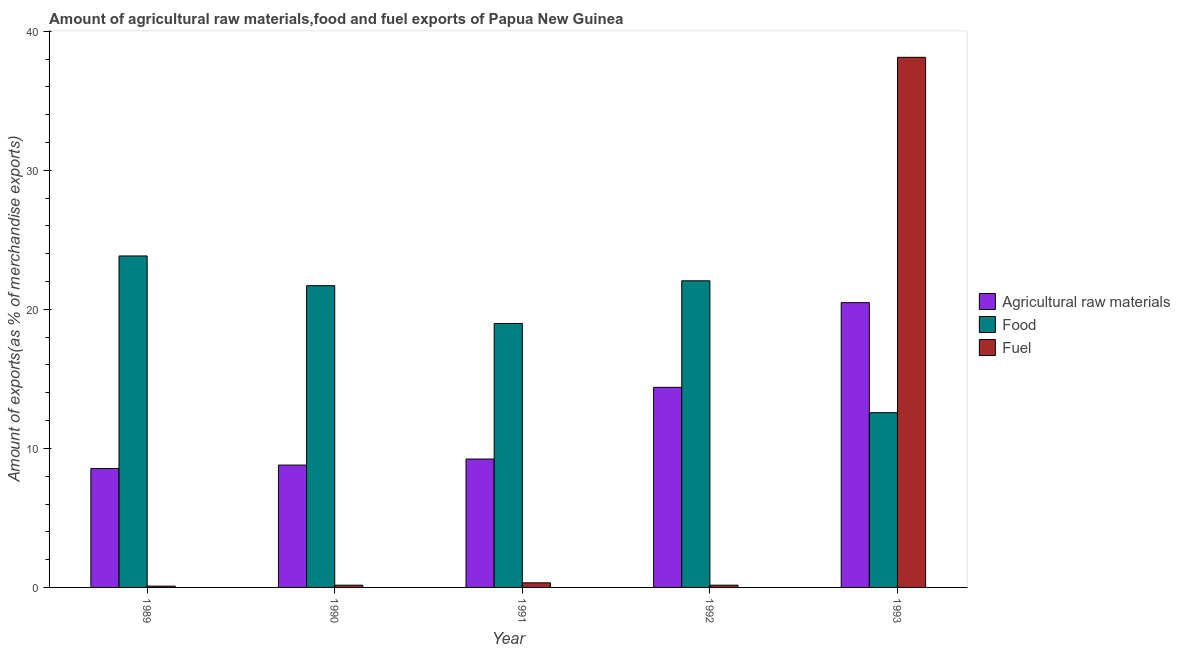How many bars are there on the 5th tick from the left?
Offer a very short reply. 3. What is the label of the 2nd group of bars from the left?
Offer a very short reply. 1990. What is the percentage of food exports in 1990?
Your answer should be compact. 21.71. Across all years, what is the maximum percentage of food exports?
Offer a terse response. 23.84. Across all years, what is the minimum percentage of fuel exports?
Give a very brief answer. 0.09. In which year was the percentage of fuel exports maximum?
Ensure brevity in your answer.  1993. In which year was the percentage of fuel exports minimum?
Your answer should be very brief. 1989. What is the total percentage of food exports in the graph?
Your answer should be very brief. 99.16. What is the difference between the percentage of fuel exports in 1991 and that in 1993?
Provide a succinct answer. -37.8. What is the difference between the percentage of fuel exports in 1989 and the percentage of raw materials exports in 1990?
Provide a short and direct response. -0.07. What is the average percentage of fuel exports per year?
Your answer should be very brief. 7.78. In the year 1991, what is the difference between the percentage of fuel exports and percentage of food exports?
Provide a short and direct response. 0. What is the ratio of the percentage of food exports in 1992 to that in 1993?
Offer a very short reply. 1.75. Is the percentage of fuel exports in 1990 less than that in 1993?
Keep it short and to the point. Yes. Is the difference between the percentage of fuel exports in 1991 and 1992 greater than the difference between the percentage of raw materials exports in 1991 and 1992?
Provide a short and direct response. No. What is the difference between the highest and the second highest percentage of fuel exports?
Offer a very short reply. 37.8. What is the difference between the highest and the lowest percentage of food exports?
Provide a succinct answer. 11.28. Is the sum of the percentage of food exports in 1992 and 1993 greater than the maximum percentage of raw materials exports across all years?
Provide a short and direct response. Yes. What does the 3rd bar from the left in 1991 represents?
Ensure brevity in your answer.  Fuel. What does the 2nd bar from the right in 1989 represents?
Offer a very short reply. Food. What is the difference between two consecutive major ticks on the Y-axis?
Offer a terse response. 10. Does the graph contain any zero values?
Ensure brevity in your answer.  No. Does the graph contain grids?
Offer a very short reply. No. How many legend labels are there?
Keep it short and to the point. 3. What is the title of the graph?
Offer a very short reply. Amount of agricultural raw materials,food and fuel exports of Papua New Guinea. Does "Resident buildings and public services" appear as one of the legend labels in the graph?
Your answer should be very brief. No. What is the label or title of the Y-axis?
Provide a short and direct response. Amount of exports(as % of merchandise exports). What is the Amount of exports(as % of merchandise exports) in Agricultural raw materials in 1989?
Keep it short and to the point. 8.56. What is the Amount of exports(as % of merchandise exports) in Food in 1989?
Your answer should be compact. 23.84. What is the Amount of exports(as % of merchandise exports) of Fuel in 1989?
Provide a succinct answer. 0.09. What is the Amount of exports(as % of merchandise exports) of Agricultural raw materials in 1990?
Give a very brief answer. 8.8. What is the Amount of exports(as % of merchandise exports) in Food in 1990?
Keep it short and to the point. 21.71. What is the Amount of exports(as % of merchandise exports) of Fuel in 1990?
Your response must be concise. 0.16. What is the Amount of exports(as % of merchandise exports) of Agricultural raw materials in 1991?
Keep it short and to the point. 9.24. What is the Amount of exports(as % of merchandise exports) in Food in 1991?
Your answer should be compact. 18.99. What is the Amount of exports(as % of merchandise exports) of Fuel in 1991?
Offer a terse response. 0.33. What is the Amount of exports(as % of merchandise exports) in Agricultural raw materials in 1992?
Provide a succinct answer. 14.39. What is the Amount of exports(as % of merchandise exports) in Food in 1992?
Give a very brief answer. 22.06. What is the Amount of exports(as % of merchandise exports) of Fuel in 1992?
Offer a terse response. 0.16. What is the Amount of exports(as % of merchandise exports) of Agricultural raw materials in 1993?
Make the answer very short. 20.49. What is the Amount of exports(as % of merchandise exports) of Food in 1993?
Keep it short and to the point. 12.57. What is the Amount of exports(as % of merchandise exports) in Fuel in 1993?
Give a very brief answer. 38.13. Across all years, what is the maximum Amount of exports(as % of merchandise exports) in Agricultural raw materials?
Offer a terse response. 20.49. Across all years, what is the maximum Amount of exports(as % of merchandise exports) in Food?
Offer a very short reply. 23.84. Across all years, what is the maximum Amount of exports(as % of merchandise exports) in Fuel?
Offer a terse response. 38.13. Across all years, what is the minimum Amount of exports(as % of merchandise exports) in Agricultural raw materials?
Provide a succinct answer. 8.56. Across all years, what is the minimum Amount of exports(as % of merchandise exports) of Food?
Provide a short and direct response. 12.57. Across all years, what is the minimum Amount of exports(as % of merchandise exports) of Fuel?
Give a very brief answer. 0.09. What is the total Amount of exports(as % of merchandise exports) of Agricultural raw materials in the graph?
Offer a terse response. 61.47. What is the total Amount of exports(as % of merchandise exports) of Food in the graph?
Your answer should be compact. 99.16. What is the total Amount of exports(as % of merchandise exports) of Fuel in the graph?
Your answer should be very brief. 38.88. What is the difference between the Amount of exports(as % of merchandise exports) of Agricultural raw materials in 1989 and that in 1990?
Offer a very short reply. -0.24. What is the difference between the Amount of exports(as % of merchandise exports) of Food in 1989 and that in 1990?
Give a very brief answer. 2.14. What is the difference between the Amount of exports(as % of merchandise exports) of Fuel in 1989 and that in 1990?
Make the answer very short. -0.07. What is the difference between the Amount of exports(as % of merchandise exports) in Agricultural raw materials in 1989 and that in 1991?
Your answer should be compact. -0.68. What is the difference between the Amount of exports(as % of merchandise exports) in Food in 1989 and that in 1991?
Provide a short and direct response. 4.86. What is the difference between the Amount of exports(as % of merchandise exports) of Fuel in 1989 and that in 1991?
Your answer should be compact. -0.24. What is the difference between the Amount of exports(as % of merchandise exports) in Agricultural raw materials in 1989 and that in 1992?
Your response must be concise. -5.84. What is the difference between the Amount of exports(as % of merchandise exports) in Food in 1989 and that in 1992?
Make the answer very short. 1.79. What is the difference between the Amount of exports(as % of merchandise exports) in Fuel in 1989 and that in 1992?
Provide a succinct answer. -0.07. What is the difference between the Amount of exports(as % of merchandise exports) in Agricultural raw materials in 1989 and that in 1993?
Ensure brevity in your answer.  -11.93. What is the difference between the Amount of exports(as % of merchandise exports) of Food in 1989 and that in 1993?
Provide a short and direct response. 11.28. What is the difference between the Amount of exports(as % of merchandise exports) in Fuel in 1989 and that in 1993?
Offer a terse response. -38.04. What is the difference between the Amount of exports(as % of merchandise exports) in Agricultural raw materials in 1990 and that in 1991?
Provide a short and direct response. -0.43. What is the difference between the Amount of exports(as % of merchandise exports) in Food in 1990 and that in 1991?
Your response must be concise. 2.72. What is the difference between the Amount of exports(as % of merchandise exports) of Fuel in 1990 and that in 1991?
Provide a succinct answer. -0.17. What is the difference between the Amount of exports(as % of merchandise exports) of Agricultural raw materials in 1990 and that in 1992?
Your answer should be compact. -5.59. What is the difference between the Amount of exports(as % of merchandise exports) of Food in 1990 and that in 1992?
Provide a succinct answer. -0.35. What is the difference between the Amount of exports(as % of merchandise exports) in Fuel in 1990 and that in 1992?
Provide a succinct answer. -0. What is the difference between the Amount of exports(as % of merchandise exports) in Agricultural raw materials in 1990 and that in 1993?
Your answer should be compact. -11.68. What is the difference between the Amount of exports(as % of merchandise exports) of Food in 1990 and that in 1993?
Your response must be concise. 9.14. What is the difference between the Amount of exports(as % of merchandise exports) of Fuel in 1990 and that in 1993?
Ensure brevity in your answer.  -37.97. What is the difference between the Amount of exports(as % of merchandise exports) in Agricultural raw materials in 1991 and that in 1992?
Offer a terse response. -5.16. What is the difference between the Amount of exports(as % of merchandise exports) of Food in 1991 and that in 1992?
Offer a very short reply. -3.07. What is the difference between the Amount of exports(as % of merchandise exports) of Fuel in 1991 and that in 1992?
Your answer should be very brief. 0.17. What is the difference between the Amount of exports(as % of merchandise exports) in Agricultural raw materials in 1991 and that in 1993?
Your response must be concise. -11.25. What is the difference between the Amount of exports(as % of merchandise exports) in Food in 1991 and that in 1993?
Your answer should be compact. 6.42. What is the difference between the Amount of exports(as % of merchandise exports) in Fuel in 1991 and that in 1993?
Provide a short and direct response. -37.8. What is the difference between the Amount of exports(as % of merchandise exports) of Agricultural raw materials in 1992 and that in 1993?
Provide a short and direct response. -6.09. What is the difference between the Amount of exports(as % of merchandise exports) in Food in 1992 and that in 1993?
Keep it short and to the point. 9.49. What is the difference between the Amount of exports(as % of merchandise exports) of Fuel in 1992 and that in 1993?
Your answer should be compact. -37.97. What is the difference between the Amount of exports(as % of merchandise exports) in Agricultural raw materials in 1989 and the Amount of exports(as % of merchandise exports) in Food in 1990?
Provide a succinct answer. -13.15. What is the difference between the Amount of exports(as % of merchandise exports) of Agricultural raw materials in 1989 and the Amount of exports(as % of merchandise exports) of Fuel in 1990?
Ensure brevity in your answer.  8.4. What is the difference between the Amount of exports(as % of merchandise exports) in Food in 1989 and the Amount of exports(as % of merchandise exports) in Fuel in 1990?
Provide a short and direct response. 23.68. What is the difference between the Amount of exports(as % of merchandise exports) in Agricultural raw materials in 1989 and the Amount of exports(as % of merchandise exports) in Food in 1991?
Ensure brevity in your answer.  -10.43. What is the difference between the Amount of exports(as % of merchandise exports) of Agricultural raw materials in 1989 and the Amount of exports(as % of merchandise exports) of Fuel in 1991?
Your answer should be compact. 8.22. What is the difference between the Amount of exports(as % of merchandise exports) in Food in 1989 and the Amount of exports(as % of merchandise exports) in Fuel in 1991?
Offer a terse response. 23.51. What is the difference between the Amount of exports(as % of merchandise exports) of Agricultural raw materials in 1989 and the Amount of exports(as % of merchandise exports) of Food in 1992?
Offer a very short reply. -13.5. What is the difference between the Amount of exports(as % of merchandise exports) in Agricultural raw materials in 1989 and the Amount of exports(as % of merchandise exports) in Fuel in 1992?
Your answer should be very brief. 8.4. What is the difference between the Amount of exports(as % of merchandise exports) of Food in 1989 and the Amount of exports(as % of merchandise exports) of Fuel in 1992?
Your response must be concise. 23.68. What is the difference between the Amount of exports(as % of merchandise exports) of Agricultural raw materials in 1989 and the Amount of exports(as % of merchandise exports) of Food in 1993?
Your response must be concise. -4.01. What is the difference between the Amount of exports(as % of merchandise exports) of Agricultural raw materials in 1989 and the Amount of exports(as % of merchandise exports) of Fuel in 1993?
Ensure brevity in your answer.  -29.57. What is the difference between the Amount of exports(as % of merchandise exports) of Food in 1989 and the Amount of exports(as % of merchandise exports) of Fuel in 1993?
Offer a very short reply. -14.29. What is the difference between the Amount of exports(as % of merchandise exports) in Agricultural raw materials in 1990 and the Amount of exports(as % of merchandise exports) in Food in 1991?
Make the answer very short. -10.19. What is the difference between the Amount of exports(as % of merchandise exports) in Agricultural raw materials in 1990 and the Amount of exports(as % of merchandise exports) in Fuel in 1991?
Provide a succinct answer. 8.47. What is the difference between the Amount of exports(as % of merchandise exports) in Food in 1990 and the Amount of exports(as % of merchandise exports) in Fuel in 1991?
Your answer should be compact. 21.37. What is the difference between the Amount of exports(as % of merchandise exports) of Agricultural raw materials in 1990 and the Amount of exports(as % of merchandise exports) of Food in 1992?
Make the answer very short. -13.26. What is the difference between the Amount of exports(as % of merchandise exports) in Agricultural raw materials in 1990 and the Amount of exports(as % of merchandise exports) in Fuel in 1992?
Give a very brief answer. 8.64. What is the difference between the Amount of exports(as % of merchandise exports) in Food in 1990 and the Amount of exports(as % of merchandise exports) in Fuel in 1992?
Offer a terse response. 21.54. What is the difference between the Amount of exports(as % of merchandise exports) in Agricultural raw materials in 1990 and the Amount of exports(as % of merchandise exports) in Food in 1993?
Ensure brevity in your answer.  -3.77. What is the difference between the Amount of exports(as % of merchandise exports) of Agricultural raw materials in 1990 and the Amount of exports(as % of merchandise exports) of Fuel in 1993?
Offer a terse response. -29.33. What is the difference between the Amount of exports(as % of merchandise exports) of Food in 1990 and the Amount of exports(as % of merchandise exports) of Fuel in 1993?
Ensure brevity in your answer.  -16.43. What is the difference between the Amount of exports(as % of merchandise exports) of Agricultural raw materials in 1991 and the Amount of exports(as % of merchandise exports) of Food in 1992?
Ensure brevity in your answer.  -12.82. What is the difference between the Amount of exports(as % of merchandise exports) in Agricultural raw materials in 1991 and the Amount of exports(as % of merchandise exports) in Fuel in 1992?
Give a very brief answer. 9.07. What is the difference between the Amount of exports(as % of merchandise exports) in Food in 1991 and the Amount of exports(as % of merchandise exports) in Fuel in 1992?
Offer a terse response. 18.83. What is the difference between the Amount of exports(as % of merchandise exports) in Agricultural raw materials in 1991 and the Amount of exports(as % of merchandise exports) in Fuel in 1993?
Make the answer very short. -28.9. What is the difference between the Amount of exports(as % of merchandise exports) in Food in 1991 and the Amount of exports(as % of merchandise exports) in Fuel in 1993?
Keep it short and to the point. -19.15. What is the difference between the Amount of exports(as % of merchandise exports) of Agricultural raw materials in 1992 and the Amount of exports(as % of merchandise exports) of Food in 1993?
Make the answer very short. 1.82. What is the difference between the Amount of exports(as % of merchandise exports) of Agricultural raw materials in 1992 and the Amount of exports(as % of merchandise exports) of Fuel in 1993?
Offer a very short reply. -23.74. What is the difference between the Amount of exports(as % of merchandise exports) in Food in 1992 and the Amount of exports(as % of merchandise exports) in Fuel in 1993?
Keep it short and to the point. -16.08. What is the average Amount of exports(as % of merchandise exports) in Agricultural raw materials per year?
Your response must be concise. 12.29. What is the average Amount of exports(as % of merchandise exports) of Food per year?
Provide a short and direct response. 19.83. What is the average Amount of exports(as % of merchandise exports) in Fuel per year?
Make the answer very short. 7.78. In the year 1989, what is the difference between the Amount of exports(as % of merchandise exports) of Agricultural raw materials and Amount of exports(as % of merchandise exports) of Food?
Make the answer very short. -15.29. In the year 1989, what is the difference between the Amount of exports(as % of merchandise exports) in Agricultural raw materials and Amount of exports(as % of merchandise exports) in Fuel?
Your answer should be very brief. 8.46. In the year 1989, what is the difference between the Amount of exports(as % of merchandise exports) of Food and Amount of exports(as % of merchandise exports) of Fuel?
Offer a terse response. 23.75. In the year 1990, what is the difference between the Amount of exports(as % of merchandise exports) of Agricultural raw materials and Amount of exports(as % of merchandise exports) of Food?
Offer a terse response. -12.9. In the year 1990, what is the difference between the Amount of exports(as % of merchandise exports) in Agricultural raw materials and Amount of exports(as % of merchandise exports) in Fuel?
Offer a terse response. 8.64. In the year 1990, what is the difference between the Amount of exports(as % of merchandise exports) of Food and Amount of exports(as % of merchandise exports) of Fuel?
Your answer should be very brief. 21.55. In the year 1991, what is the difference between the Amount of exports(as % of merchandise exports) in Agricultural raw materials and Amount of exports(as % of merchandise exports) in Food?
Provide a short and direct response. -9.75. In the year 1991, what is the difference between the Amount of exports(as % of merchandise exports) of Agricultural raw materials and Amount of exports(as % of merchandise exports) of Fuel?
Give a very brief answer. 8.9. In the year 1991, what is the difference between the Amount of exports(as % of merchandise exports) in Food and Amount of exports(as % of merchandise exports) in Fuel?
Provide a short and direct response. 18.65. In the year 1992, what is the difference between the Amount of exports(as % of merchandise exports) in Agricultural raw materials and Amount of exports(as % of merchandise exports) in Food?
Keep it short and to the point. -7.66. In the year 1992, what is the difference between the Amount of exports(as % of merchandise exports) of Agricultural raw materials and Amount of exports(as % of merchandise exports) of Fuel?
Offer a very short reply. 14.23. In the year 1992, what is the difference between the Amount of exports(as % of merchandise exports) of Food and Amount of exports(as % of merchandise exports) of Fuel?
Your response must be concise. 21.89. In the year 1993, what is the difference between the Amount of exports(as % of merchandise exports) in Agricultural raw materials and Amount of exports(as % of merchandise exports) in Food?
Make the answer very short. 7.92. In the year 1993, what is the difference between the Amount of exports(as % of merchandise exports) of Agricultural raw materials and Amount of exports(as % of merchandise exports) of Fuel?
Offer a terse response. -17.65. In the year 1993, what is the difference between the Amount of exports(as % of merchandise exports) in Food and Amount of exports(as % of merchandise exports) in Fuel?
Provide a succinct answer. -25.56. What is the ratio of the Amount of exports(as % of merchandise exports) of Agricultural raw materials in 1989 to that in 1990?
Your answer should be very brief. 0.97. What is the ratio of the Amount of exports(as % of merchandise exports) in Food in 1989 to that in 1990?
Offer a terse response. 1.1. What is the ratio of the Amount of exports(as % of merchandise exports) of Fuel in 1989 to that in 1990?
Provide a short and direct response. 0.58. What is the ratio of the Amount of exports(as % of merchandise exports) in Agricultural raw materials in 1989 to that in 1991?
Offer a very short reply. 0.93. What is the ratio of the Amount of exports(as % of merchandise exports) of Food in 1989 to that in 1991?
Make the answer very short. 1.26. What is the ratio of the Amount of exports(as % of merchandise exports) of Fuel in 1989 to that in 1991?
Provide a short and direct response. 0.28. What is the ratio of the Amount of exports(as % of merchandise exports) in Agricultural raw materials in 1989 to that in 1992?
Keep it short and to the point. 0.59. What is the ratio of the Amount of exports(as % of merchandise exports) in Food in 1989 to that in 1992?
Keep it short and to the point. 1.08. What is the ratio of the Amount of exports(as % of merchandise exports) of Fuel in 1989 to that in 1992?
Offer a terse response. 0.58. What is the ratio of the Amount of exports(as % of merchandise exports) in Agricultural raw materials in 1989 to that in 1993?
Keep it short and to the point. 0.42. What is the ratio of the Amount of exports(as % of merchandise exports) in Food in 1989 to that in 1993?
Offer a very short reply. 1.9. What is the ratio of the Amount of exports(as % of merchandise exports) of Fuel in 1989 to that in 1993?
Offer a very short reply. 0. What is the ratio of the Amount of exports(as % of merchandise exports) in Agricultural raw materials in 1990 to that in 1991?
Offer a terse response. 0.95. What is the ratio of the Amount of exports(as % of merchandise exports) in Food in 1990 to that in 1991?
Your response must be concise. 1.14. What is the ratio of the Amount of exports(as % of merchandise exports) of Fuel in 1990 to that in 1991?
Offer a very short reply. 0.48. What is the ratio of the Amount of exports(as % of merchandise exports) of Agricultural raw materials in 1990 to that in 1992?
Offer a terse response. 0.61. What is the ratio of the Amount of exports(as % of merchandise exports) in Food in 1990 to that in 1992?
Your response must be concise. 0.98. What is the ratio of the Amount of exports(as % of merchandise exports) in Agricultural raw materials in 1990 to that in 1993?
Offer a very short reply. 0.43. What is the ratio of the Amount of exports(as % of merchandise exports) in Food in 1990 to that in 1993?
Your answer should be very brief. 1.73. What is the ratio of the Amount of exports(as % of merchandise exports) of Fuel in 1990 to that in 1993?
Your answer should be compact. 0. What is the ratio of the Amount of exports(as % of merchandise exports) in Agricultural raw materials in 1991 to that in 1992?
Your answer should be very brief. 0.64. What is the ratio of the Amount of exports(as % of merchandise exports) of Food in 1991 to that in 1992?
Offer a very short reply. 0.86. What is the ratio of the Amount of exports(as % of merchandise exports) in Fuel in 1991 to that in 1992?
Your answer should be compact. 2.06. What is the ratio of the Amount of exports(as % of merchandise exports) in Agricultural raw materials in 1991 to that in 1993?
Provide a succinct answer. 0.45. What is the ratio of the Amount of exports(as % of merchandise exports) of Food in 1991 to that in 1993?
Your answer should be compact. 1.51. What is the ratio of the Amount of exports(as % of merchandise exports) in Fuel in 1991 to that in 1993?
Provide a short and direct response. 0.01. What is the ratio of the Amount of exports(as % of merchandise exports) in Agricultural raw materials in 1992 to that in 1993?
Provide a succinct answer. 0.7. What is the ratio of the Amount of exports(as % of merchandise exports) in Food in 1992 to that in 1993?
Ensure brevity in your answer.  1.75. What is the ratio of the Amount of exports(as % of merchandise exports) in Fuel in 1992 to that in 1993?
Give a very brief answer. 0. What is the difference between the highest and the second highest Amount of exports(as % of merchandise exports) in Agricultural raw materials?
Your response must be concise. 6.09. What is the difference between the highest and the second highest Amount of exports(as % of merchandise exports) of Food?
Provide a succinct answer. 1.79. What is the difference between the highest and the second highest Amount of exports(as % of merchandise exports) in Fuel?
Your answer should be very brief. 37.8. What is the difference between the highest and the lowest Amount of exports(as % of merchandise exports) of Agricultural raw materials?
Provide a succinct answer. 11.93. What is the difference between the highest and the lowest Amount of exports(as % of merchandise exports) in Food?
Your answer should be compact. 11.28. What is the difference between the highest and the lowest Amount of exports(as % of merchandise exports) in Fuel?
Ensure brevity in your answer.  38.04. 